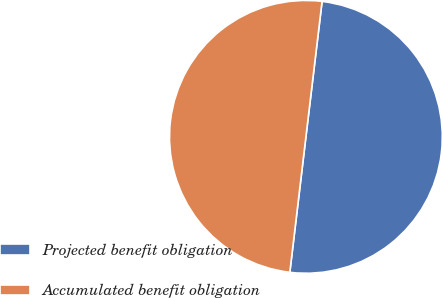Convert chart. <chart><loc_0><loc_0><loc_500><loc_500><pie_chart><fcel>Projected benefit obligation<fcel>Accumulated benefit obligation<nl><fcel>49.99%<fcel>50.01%<nl></chart> 